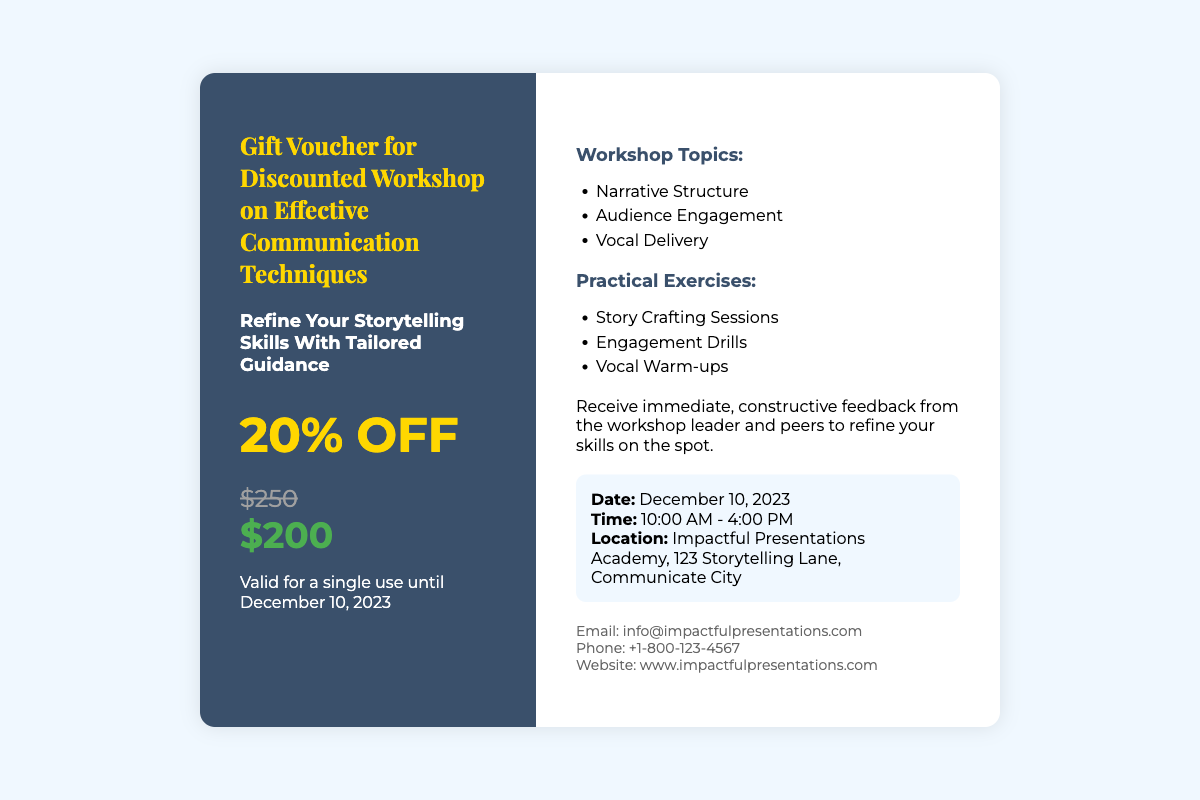what is the original price of the workshop? The original price of the workshop is mentioned in the document as $250.
Answer: $250 what is the discounted price? The discounted price is specified as $200 after applying the 20% off.
Answer: $200 when is the workshop scheduled? The document states that the workshop is scheduled for December 10, 2023.
Answer: December 10, 2023 how much discount is offered? The voucher offers a discount of 20% off the original price.
Answer: 20% OFF what topics will be covered in the workshop? The document lists topics such as Narrative Structure, Audience Engagement, and Vocal Delivery.
Answer: Narrative Structure, Audience Engagement, Vocal Delivery what is the duration of the workshop? The timing of the workshop is from 10:00 AM to 4:00 PM, indicating a duration of 6 hours.
Answer: 6 hours where will the workshop take place? The location of the workshop is mentioned as Impactful Presentations Academy, 123 Storytelling Lane, Communicate City.
Answer: Impactful Presentations Academy, 123 Storytelling Lane, Communicate City what type of feedback will participants receive? The document states that participants will receive immediate, constructive feedback from the workshop leader and peers.
Answer: Immediate, constructive feedback what is the validity period of the voucher? The voucher is valid for a single use until December 10, 2023.
Answer: Until December 10, 2023 